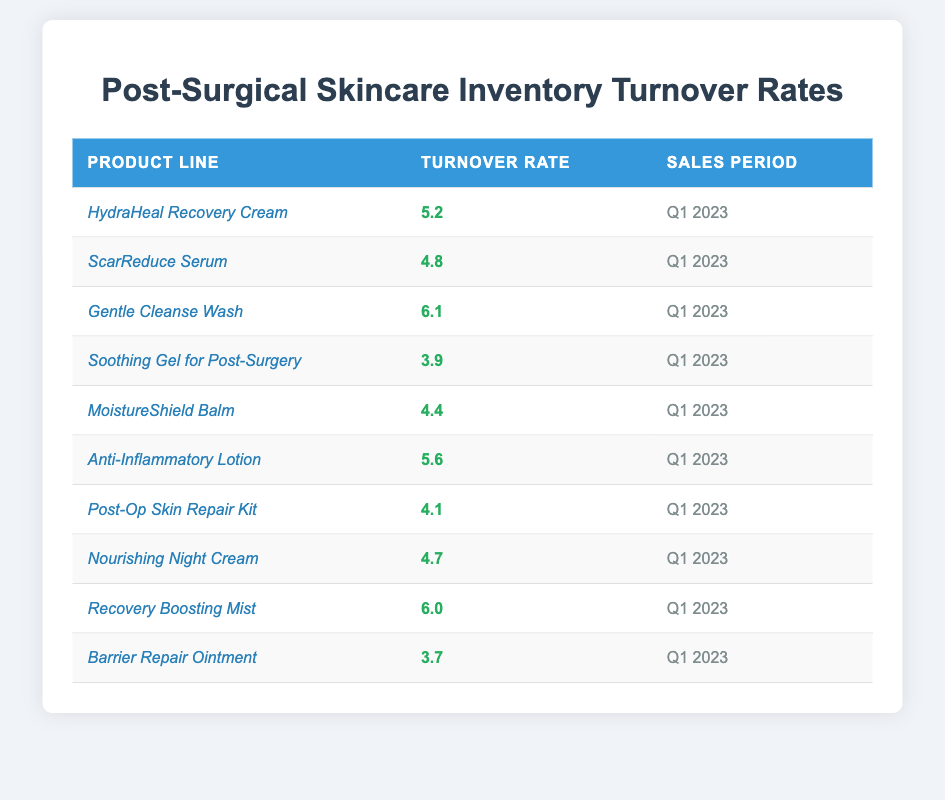What is the turnover rate for the "Gentle Cleanse Wash"? The table shows that the turnover rate for the "Gentle Cleanse Wash" is listed directly in the corresponding row.
Answer: 6.1 Which product line has the lowest turnover rate? By examining the turnover rates in the table, the lowest value is found for "Barrier Repair Ointment" at 3.7.
Answer: 3.7 What is the average turnover rate of all product lines listed? To find the average, sum all turnover rates (5.2 + 4.8 + 6.1 + 3.9 + 4.4 + 5.6 + 4.1 + 4.7 + 6.0 + 3.7 = 57.5) and divide by the number of product lines (10), resulting in an average of 57.5 / 10 = 5.75.
Answer: 5.75 Is the turnover rate of "Recovery Boosting Mist" higher than that of "HydraHeal Recovery Cream"? Comparison of the rates in the table shows "Recovery Boosting Mist" at 6.0 and "HydraHeal Recovery Cream" at 5.2, indicating that 6.0 is greater than 5.2.
Answer: Yes How many product lines have a turnover rate above 5? Count the product lines with turnover rates greater than 5 directly from the table. The qualifying product lines are "HydraHeal Recovery Cream", "Gentle Cleanse Wash", "Anti-Inflammatory Lotion", and "Recovery Boosting Mist", totaling 4 lines.
Answer: 4 What is the difference between the highest and lowest turnover rates? Identifying the highest turnover rate (6.1 for "Gentle Cleanse Wash") and the lowest (3.7 for "Barrier Repair Ointment") allows us to subtract: 6.1 - 3.7 = 2.4.
Answer: 2.4 Which product line's turnover rate is closest to 5? Evaluating the turnover rates around 5 shows "HydraHeal Recovery Cream" (5.2) and "Anti-Inflammatory Lotion" (5.6) are both close, but "HydraHeal Recovery Cream" is slightly closer as it differs by only 0.2.
Answer: HydraHeal Recovery Cream Can we conclude that all product lines have a turnover rate above 3? Checking the values in the table reveals that the lowest rate is 3.7, meaning all product lines indeed exceed 3.
Answer: Yes What percentage of the product lines have a turnover rate below 5? Identify the product lines below 5: "Soothing Gel for Post-Surgery" (3.9), "MoistureShield Balm" (4.4), "Post-Op Skin Repair Kit" (4.1), "Nourishing Night Cream" (4.7), and "Barrier Repair Ointment" (3.7), totaling 5 out of 10 lines, equating to 50%.
Answer: 50% 